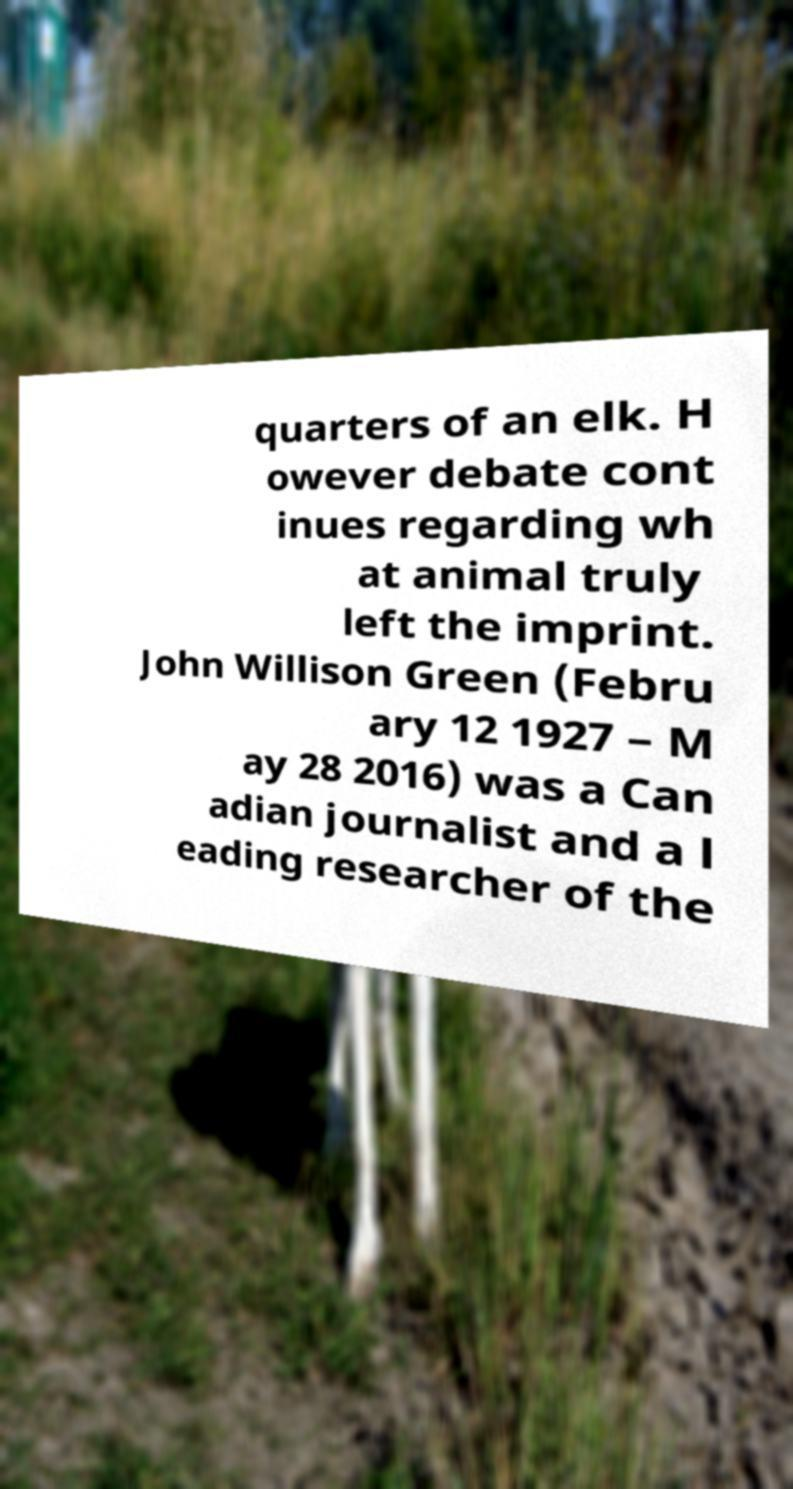Can you read and provide the text displayed in the image?This photo seems to have some interesting text. Can you extract and type it out for me? quarters of an elk. H owever debate cont inues regarding wh at animal truly left the imprint. John Willison Green (Febru ary 12 1927 – M ay 28 2016) was a Can adian journalist and a l eading researcher of the 